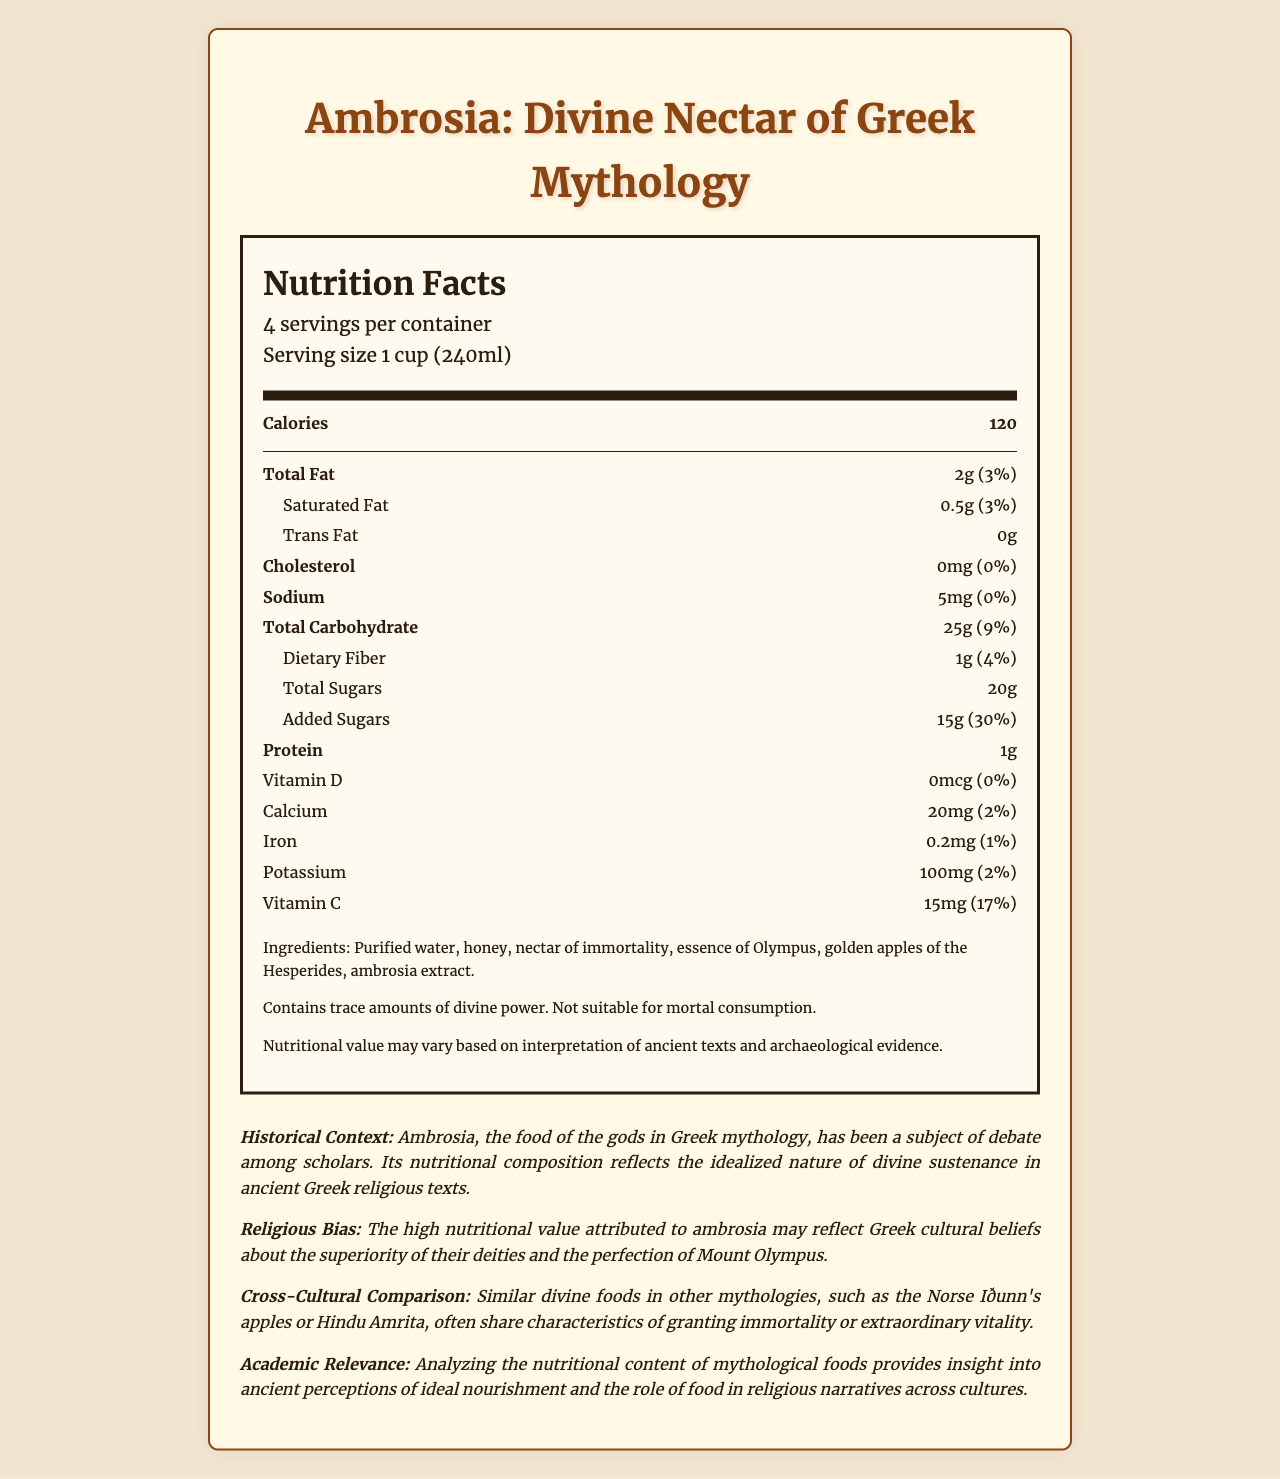what is the serving size? The serving size is specified in the serving information section as "1 cup (240ml)".
Answer: 1 cup (240ml) how many servings are in the container? The document states that there are "4 servings per container".
Answer: 4 how many calories are there per serving? The calories section clearly shows that there are 120 calories per serving.
Answer: 120 what amount of Total Fat is present per serving? The Total Fat is listed as "2g" in the nutrient breakdown.
Answer: 2g what is the percentage of daily value for added sugars? The amount of added sugars per serving is given as "15g (30%)".
Answer: 30% what ingredients are in the product? The ingredients are listed in the additional information section.
Answer: Purified water, honey, nectar of immortality, essence of Olympus, golden apples of the Hesperides, ambrosia extract how much vitamin C is in a serving? The document lists the Vitamin C content as "15mg (17%)".
Answer: 15mg how much protein is in one serving? The protein content per serving is specified as "1g".
Answer: 1g which nutrient has the highest percentage of daily value? A. Total Fat B. Total Carbohydrate C. Added Sugars D. Vitamin C Added Sugars have a daily value percentage of 30%, which is the highest among the listed nutrients.
Answer: C. Added Sugars what is the historical context mentioned in the document? This information is provided in the historical context section of the document.
Answer: Ambrosia, the food of the gods in Greek mythology, has been a subject of debate among scholars. is this product suitable for mortal consumption? The document states "Not suitable for mortal consumption" in the additional info section.
Answer: No what does the document say about cross-cultural comparison of divine foods? This is found in the cross-cultural comparison section.
Answer: It mentions that similar divine foods in other mythologies, such as the Norse Iðunn's apples or Hindu Amrita, often share characteristics of granting immortality or extraordinary vitality. does the product contain any cholesterol? The document specifies that the cholesterol amount is "0mg (0%)".
Answer: No how much sodium is in one serving? The sodium content per serving is given as "5mg (0%)".
Answer: 5mg summarize the main idea of the document. The summary includes key highlights of the document, detailing its main focus areas.
Answer: The document is a nutrition facts label for "Ambrosia: Divine Nectar of Greek Mythology," featuring information on its nutritional content, ingredients, historical context, religious bias, cross-cultural comparison, and academic relevance. how has religious bias influenced the nutritional value of ambrosia? This is stated in the religious bias section of the document.
Answer: The high nutritional value attributed to ambrosia may reflect Greek cultural beliefs about the superiority of their deities and the perfection of Mount Olympus. what is the purpose of analyzing the nutritional content of mythological foods according to the document? This purpose is mentioned in the academic relevance section.
Answer: It provides insight into ancient perceptions of ideal nourishment and the role of food in religious narratives across cultures. what is the amount of calcium per serving? The document lists the calcium content as "20mg (2%)".
Answer: 20mg what is the main source of sugars in the product? The document lists the total sugars and added sugars but doesn't specify their sources.
Answer: Cannot be determined how is the document designed? A. With Serif Fonts B. Using a Handwritten Style C. With Sans-Serif Fonts D. In a Gothic Theme The document uses 'Merriweather', a serif font, in its styling as detailed in the HTML/CSS section of the code which specifies the font family 'Merriweather'.
Answer: A. With Serif Fonts 